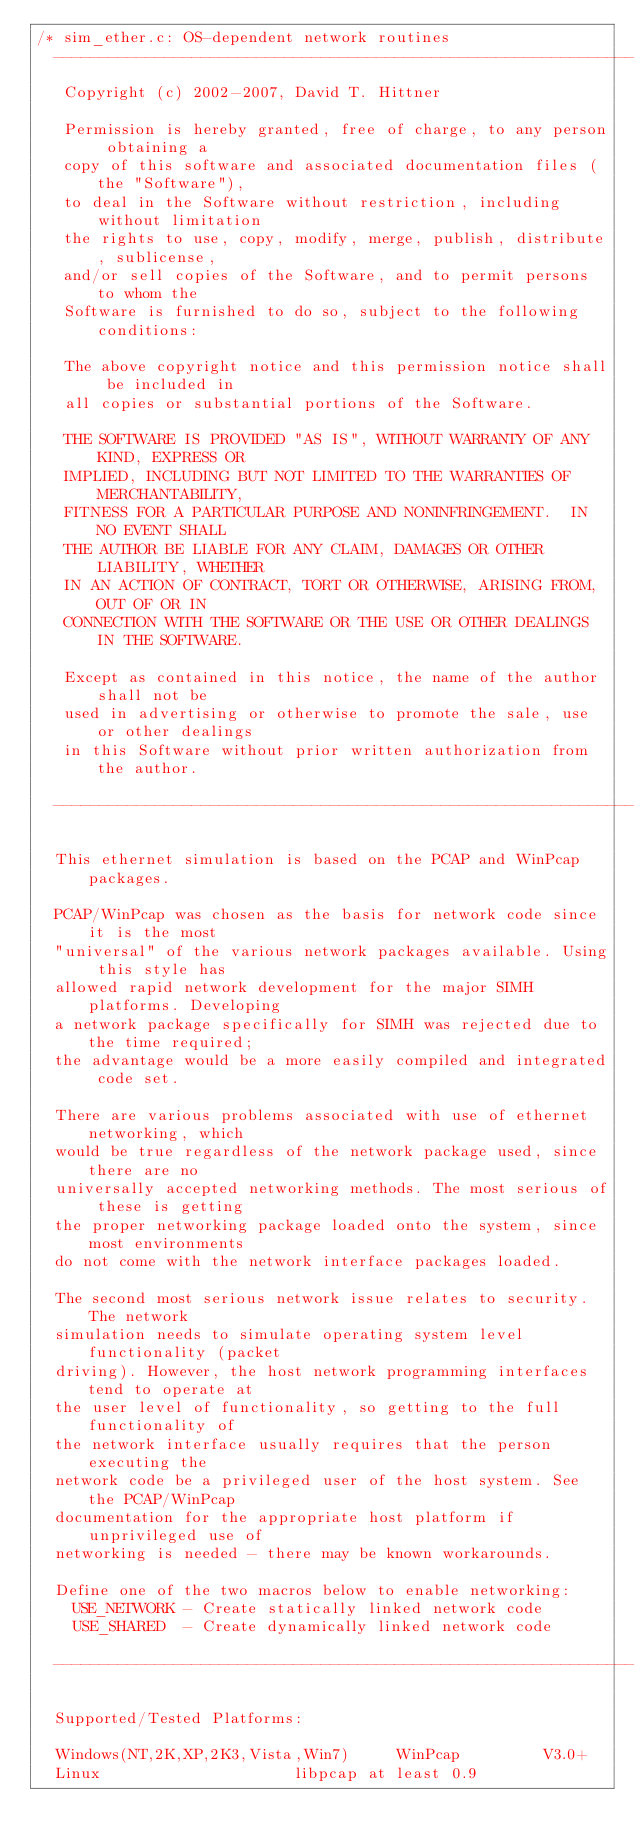<code> <loc_0><loc_0><loc_500><loc_500><_C_>/* sim_ether.c: OS-dependent network routines
  ------------------------------------------------------------------------------
   Copyright (c) 2002-2007, David T. Hittner

   Permission is hereby granted, free of charge, to any person obtaining a
   copy of this software and associated documentation files (the "Software"),
   to deal in the Software without restriction, including without limitation
   the rights to use, copy, modify, merge, publish, distribute, sublicense,
   and/or sell copies of the Software, and to permit persons to whom the
   Software is furnished to do so, subject to the following conditions:

   The above copyright notice and this permission notice shall be included in
   all copies or substantial portions of the Software.

   THE SOFTWARE IS PROVIDED "AS IS", WITHOUT WARRANTY OF ANY KIND, EXPRESS OR
   IMPLIED, INCLUDING BUT NOT LIMITED TO THE WARRANTIES OF MERCHANTABILITY,
   FITNESS FOR A PARTICULAR PURPOSE AND NONINFRINGEMENT.  IN NO EVENT SHALL
   THE AUTHOR BE LIABLE FOR ANY CLAIM, DAMAGES OR OTHER LIABILITY, WHETHER
   IN AN ACTION OF CONTRACT, TORT OR OTHERWISE, ARISING FROM, OUT OF OR IN
   CONNECTION WITH THE SOFTWARE OR THE USE OR OTHER DEALINGS IN THE SOFTWARE.

   Except as contained in this notice, the name of the author shall not be
   used in advertising or otherwise to promote the sale, use or other dealings
   in this Software without prior written authorization from the author.

  ------------------------------------------------------------------------------

  This ethernet simulation is based on the PCAP and WinPcap packages.

  PCAP/WinPcap was chosen as the basis for network code since it is the most
  "universal" of the various network packages available. Using this style has
  allowed rapid network development for the major SIMH platforms. Developing
  a network package specifically for SIMH was rejected due to the time required;
  the advantage would be a more easily compiled and integrated code set.

  There are various problems associated with use of ethernet networking, which
  would be true regardless of the network package used, since there are no
  universally accepted networking methods. The most serious of these is getting
  the proper networking package loaded onto the system, since most environments
  do not come with the network interface packages loaded.

  The second most serious network issue relates to security. The network
  simulation needs to simulate operating system level functionality (packet
  driving). However, the host network programming interfaces tend to operate at
  the user level of functionality, so getting to the full functionality of
  the network interface usually requires that the person executing the
  network code be a privileged user of the host system. See the PCAP/WinPcap
  documentation for the appropriate host platform if unprivileged use of
  networking is needed - there may be known workarounds.

  Define one of the two macros below to enable networking:
    USE_NETWORK - Create statically linked network code
    USE_SHARED  - Create dynamically linked network code

  ------------------------------------------------------------------------------

  Supported/Tested Platforms:

  Windows(NT,2K,XP,2K3,Vista,Win7)     WinPcap         V3.0+
  Linux                     libpcap at least 0.9</code> 